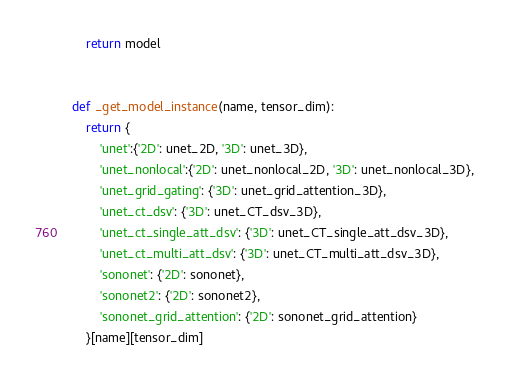<code> <loc_0><loc_0><loc_500><loc_500><_Python_>
    return model


def _get_model_instance(name, tensor_dim):
    return {
        'unet':{'2D': unet_2D, '3D': unet_3D},
        'unet_nonlocal':{'2D': unet_nonlocal_2D, '3D': unet_nonlocal_3D},
        'unet_grid_gating': {'3D': unet_grid_attention_3D},
        'unet_ct_dsv': {'3D': unet_CT_dsv_3D},
        'unet_ct_single_att_dsv': {'3D': unet_CT_single_att_dsv_3D},
        'unet_ct_multi_att_dsv': {'3D': unet_CT_multi_att_dsv_3D},
        'sononet': {'2D': sononet},
        'sononet2': {'2D': sononet2},
        'sononet_grid_attention': {'2D': sononet_grid_attention}
    }[name][tensor_dim]
</code> 